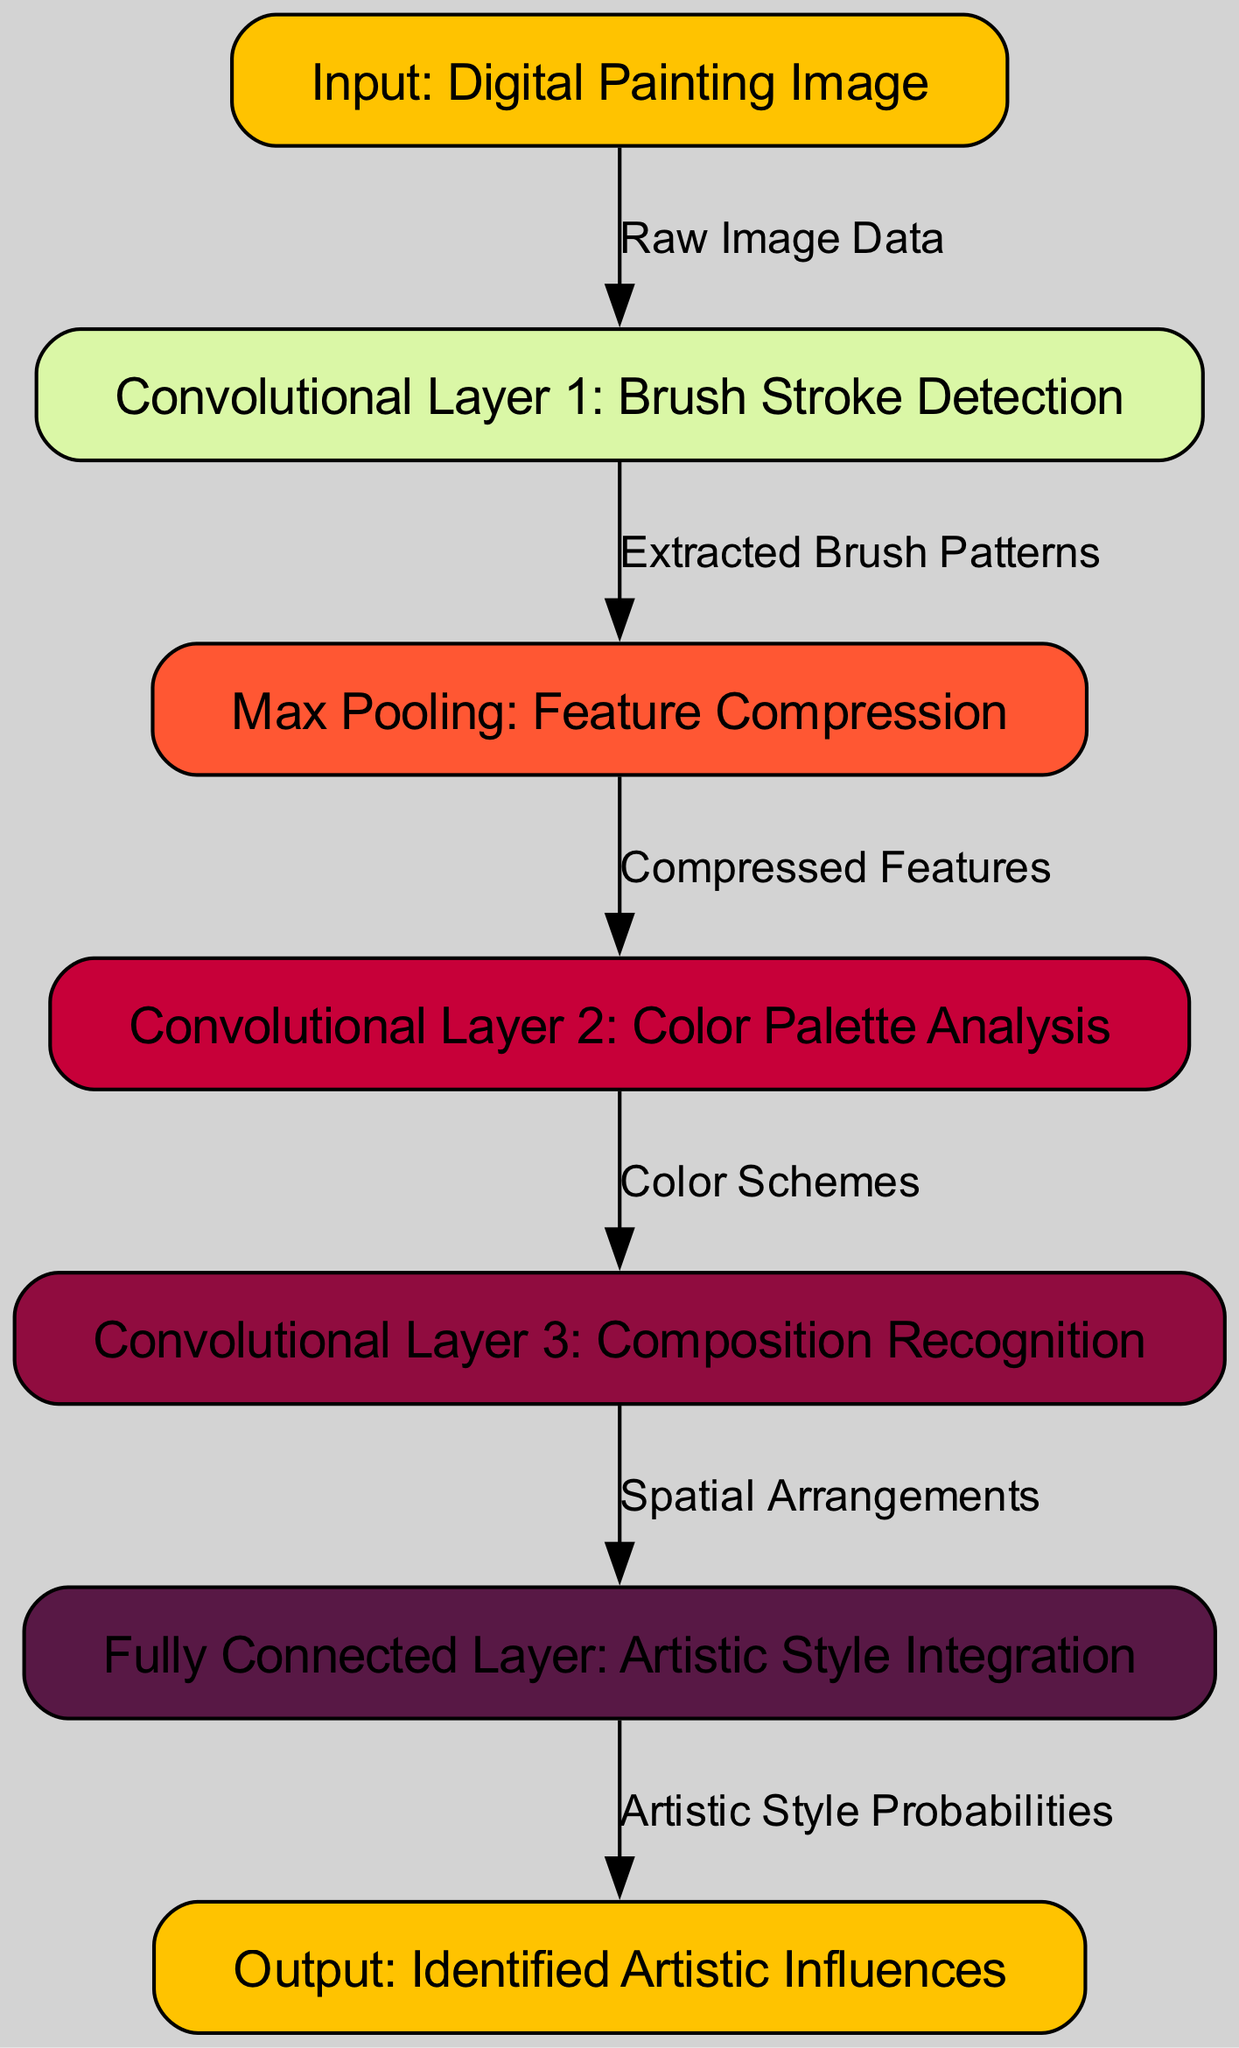What is the input node labeled as? The input node represents the starting point of the diagram, which is labeled "Input: Digital Painting Image."
Answer: Input: Digital Painting Image How many convolutional layers are in the diagram? The diagram includes three convolutional layers: Convolutional Layer 1, Convolutional Layer 2, and Convolutional Layer 3.
Answer: 3 What label does the output node have? The output node conveys the final result of the process, which is labeled "Output: Identified Artistic Influences."
Answer: Output: Identified Artistic Influences What is the purpose of the Max Pooling layer? The Max Pooling layer, labeled as "Max Pooling: Feature Compression," is designed to compress the features extracted from the previous layer.
Answer: Feature Compression Which layer analyzes color palettes? The layer specifically dedicated to analyzing color palettes is labeled "Convolutional Layer 2: Color Palette Analysis."
Answer: Convolutional Layer 2: Color Palette Analysis What is the relationship between Convolutional Layer 1 and the Fully Connected Layer? Convolutional Layer 1 leads to Max Pooling, which connects to Convolutional Layer 2, eventually continuing to Convolutional Layer 3 before reaching the Fully Connected Layer.
Answer: Convolutional Layer 1 to Fully Connected Layer through intermediate layers What two types of analyses are performed before the Fully Connected Layer? The two analyses performed are "Composition Recognition" in Convolutional Layer 3 and "Color Palette Analysis" in Convolutional Layer 2.
Answer: Composition Recognition and Color Palette Analysis What do the edges represent in the diagram? The edges in the diagram illustrate the flow of data and the relationships between nodes, indicating how the information progresses through the network.
Answer: Flow of data and relationships What is extracted after Convolutional Layer 1? After Convolutional Layer 1, the extracted feature is referred to as "Extracted Brush Patterns," which details the brush strokes detected.
Answer: Extracted Brush Patterns 